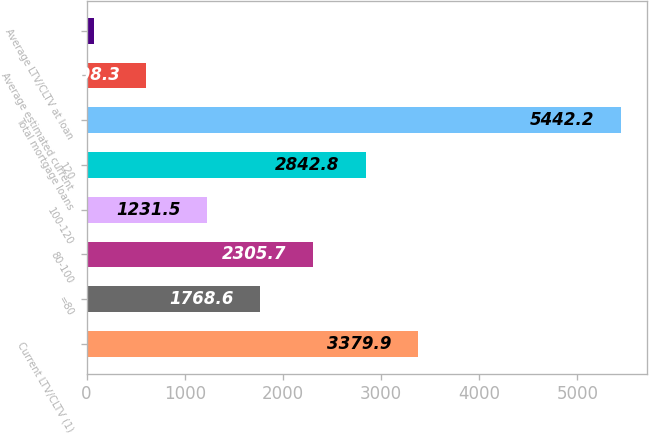Convert chart to OTSL. <chart><loc_0><loc_0><loc_500><loc_500><bar_chart><fcel>Current LTV/CLTV (1)<fcel>=80<fcel>80-100<fcel>100-120<fcel>120<fcel>Total mortgage loans<fcel>Average estimated current<fcel>Average LTV/CLTV at loan<nl><fcel>3379.9<fcel>1768.6<fcel>2305.7<fcel>1231.5<fcel>2842.8<fcel>5442.2<fcel>608.3<fcel>71.2<nl></chart> 